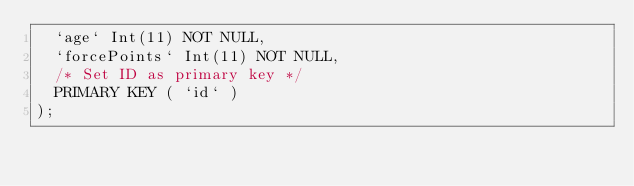Convert code to text. <code><loc_0><loc_0><loc_500><loc_500><_SQL_>	`age` Int(11) NOT NULL,
	`forcePoints` Int(11) NOT NULL,
	/* Set ID as primary key */
	PRIMARY KEY ( `id` )
);
</code> 